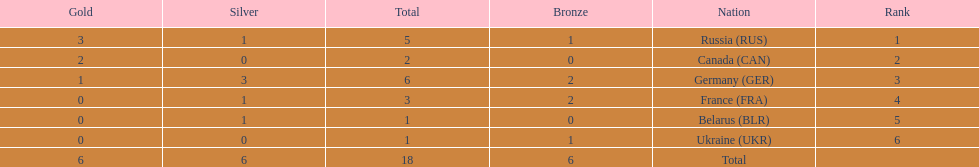Who had a larger total medal count, france or canada? France. 